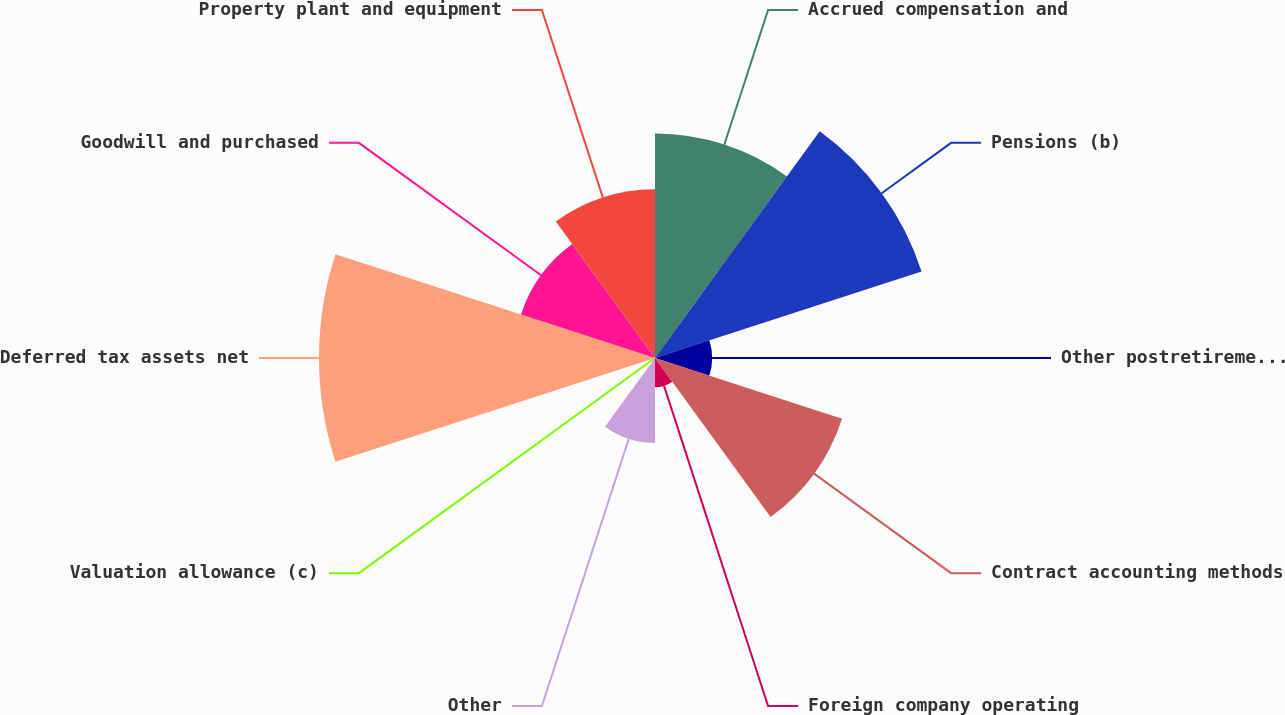<chart> <loc_0><loc_0><loc_500><loc_500><pie_chart><fcel>Accrued compensation and<fcel>Pensions (b)<fcel>Other postretirement benefit<fcel>Contract accounting methods<fcel>Foreign company operating<fcel>Other<fcel>Valuation allowance (c)<fcel>Deferred tax assets net<fcel>Goodwill and purchased<fcel>Property plant and equipment<nl><fcel>14.77%<fcel>18.44%<fcel>3.76%<fcel>12.94%<fcel>1.93%<fcel>5.6%<fcel>0.09%<fcel>22.11%<fcel>9.27%<fcel>11.1%<nl></chart> 